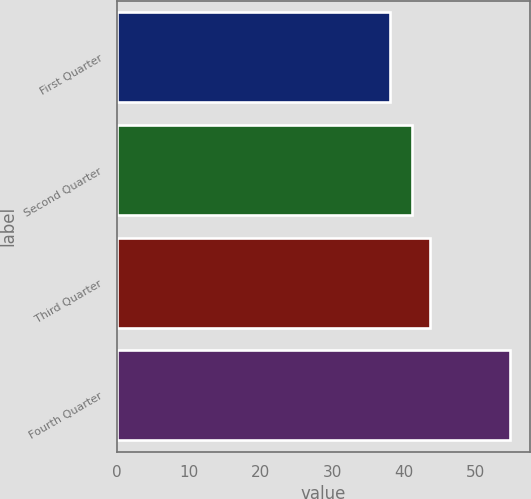Convert chart to OTSL. <chart><loc_0><loc_0><loc_500><loc_500><bar_chart><fcel>First Quarter<fcel>Second Quarter<fcel>Third Quarter<fcel>Fourth Quarter<nl><fcel>38.02<fcel>41.2<fcel>43.69<fcel>54.84<nl></chart> 